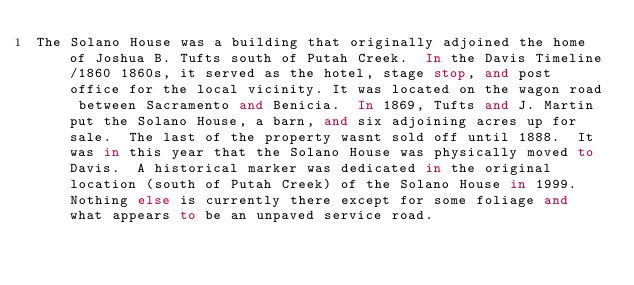Convert code to text. <code><loc_0><loc_0><loc_500><loc_500><_FORTRAN_>The Solano House was a building that originally adjoined the home of Joshua B. Tufts south of Putah Creek.  In the Davis Timeline/1860 1860s, it served as the hotel, stage stop, and post office for the local vicinity. It was located on the wagon road between Sacramento and Benicia.  In 1869, Tufts and J. Martin put the Solano House, a barn, and six adjoining acres up for sale.  The last of the property wasnt sold off until 1888.  It was in this year that the Solano House was physically moved to Davis.  A historical marker was dedicated in the original location (south of Putah Creek) of the Solano House in 1999.  Nothing else is currently there except for some foliage and what appears to be an unpaved service road.
</code> 